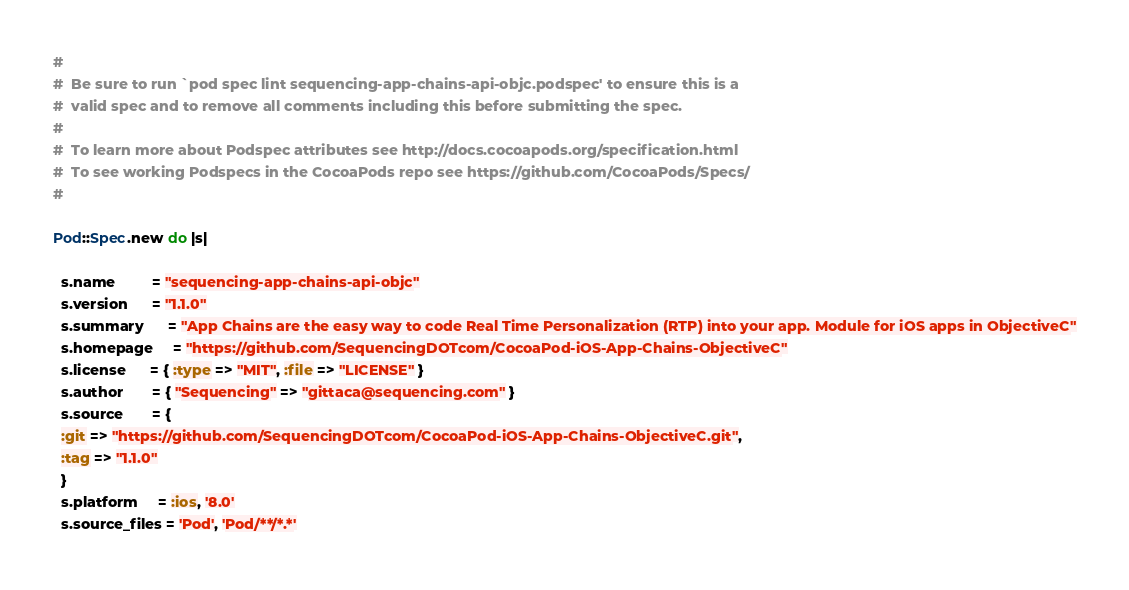<code> <loc_0><loc_0><loc_500><loc_500><_Ruby_>#
#  Be sure to run `pod spec lint sequencing-app-chains-api-objc.podspec' to ensure this is a
#  valid spec and to remove all comments including this before submitting the spec.
#
#  To learn more about Podspec attributes see http://docs.cocoapods.org/specification.html
#  To see working Podspecs in the CocoaPods repo see https://github.com/CocoaPods/Specs/
#

Pod::Spec.new do |s|

  s.name         = "sequencing-app-chains-api-objc"
  s.version      = "1.1.0"
  s.summary      = "App Chains are the easy way to code Real Time Personalization (RTP) into your app. Module for iOS apps in ObjectiveC"
  s.homepage     = "https://github.com/SequencingDOTcom/CocoaPod-iOS-App-Chains-ObjectiveC"
  s.license      = { :type => "MIT", :file => "LICENSE" }
  s.author       = { "Sequencing" => "gittaca@sequencing.com" }
  s.source       = { 
  :git => "https://github.com/SequencingDOTcom/CocoaPod-iOS-App-Chains-ObjectiveC.git", 
  :tag => "1.1.0" 
  }
  s.platform     = :ios, '8.0'
  s.source_files = 'Pod', 'Pod/**/*.*'  </code> 